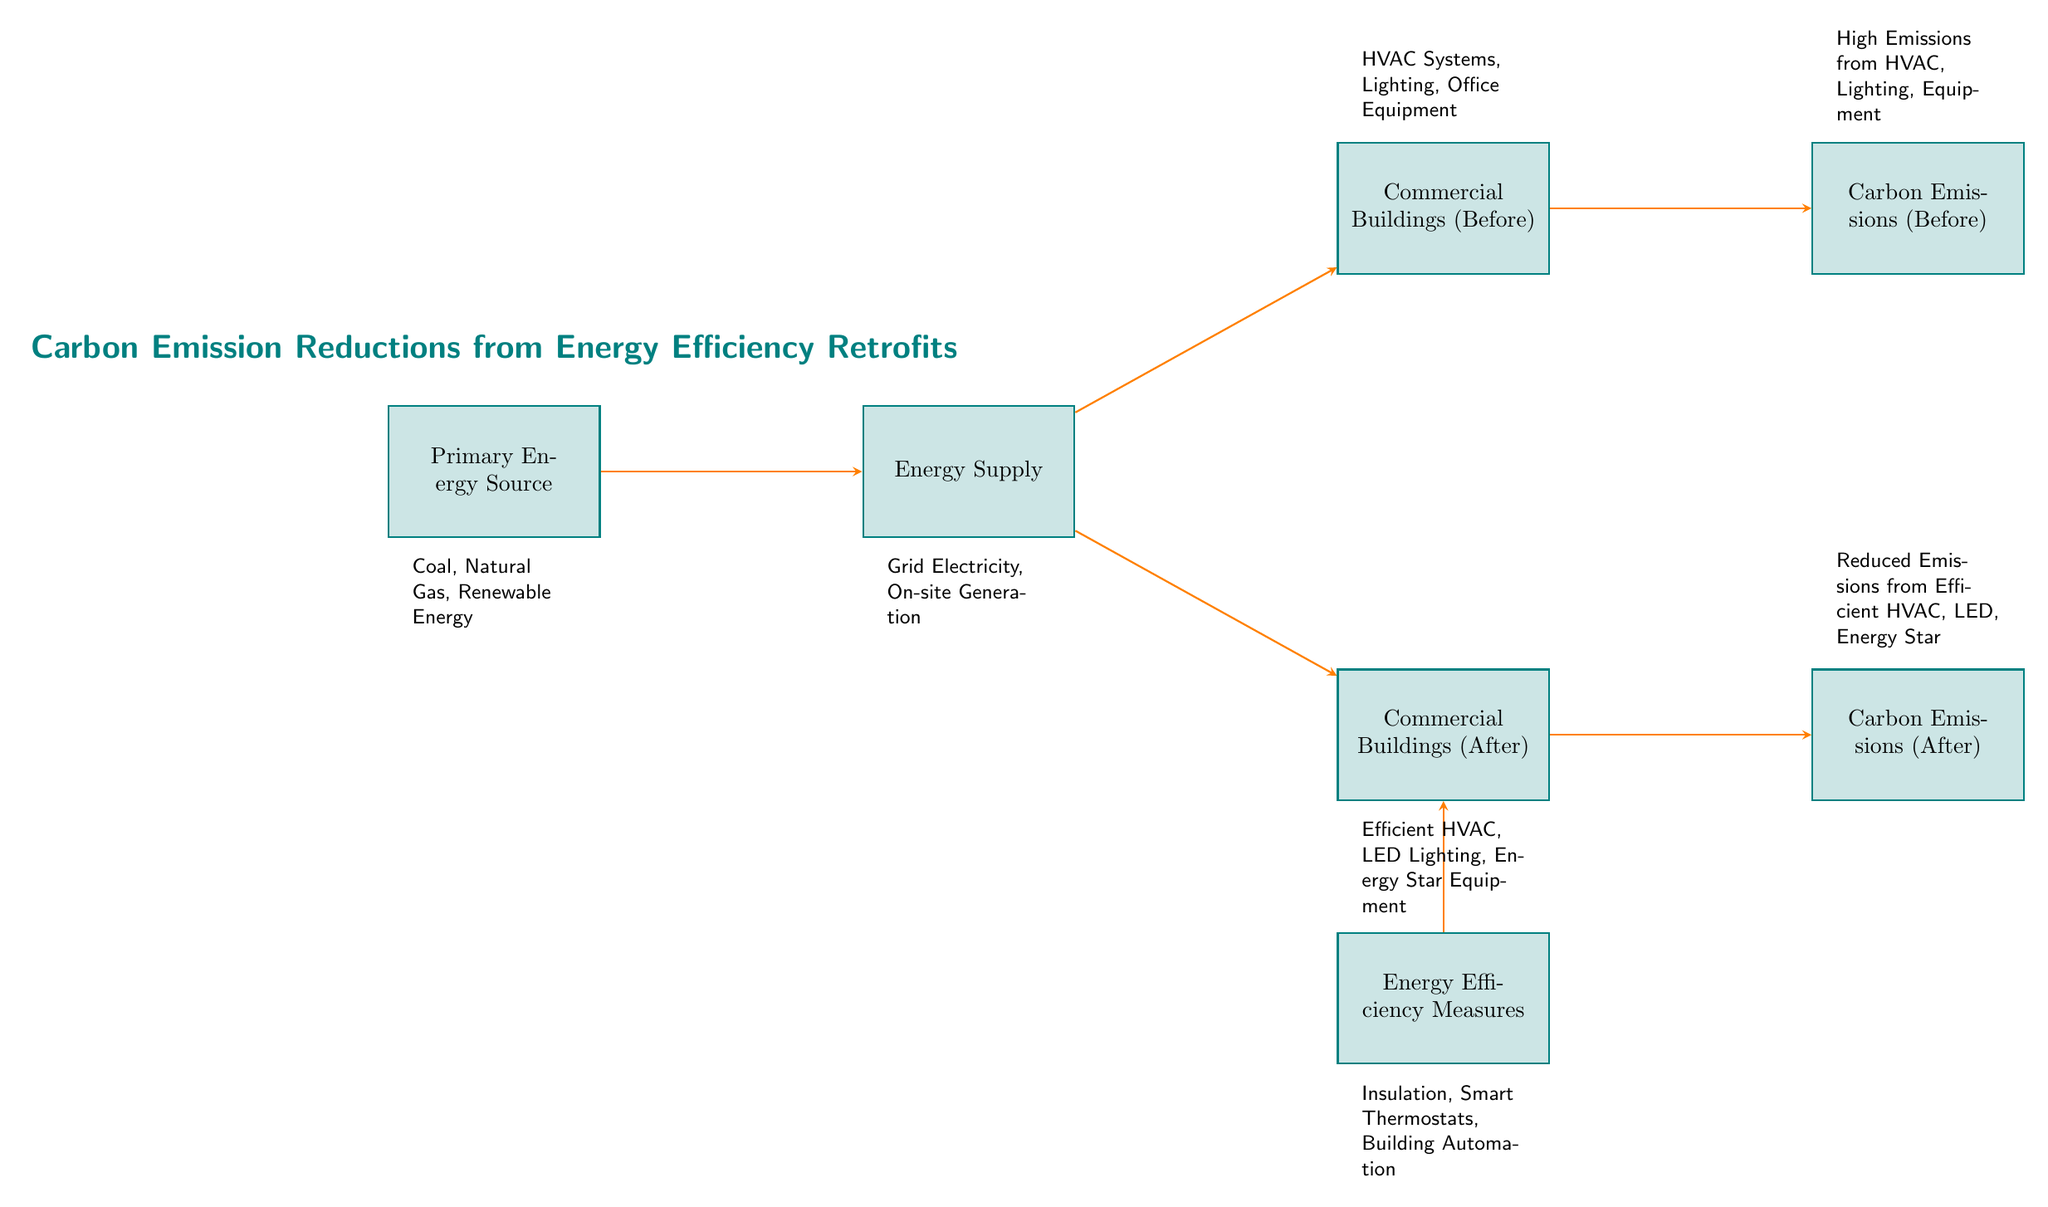What are the primary energy sources shown in the diagram? The diagram identifies the primary energy sources as coal, natural gas, and renewable energy, all listed below the 'Primary Energy Source' node.
Answer: Coal, Natural Gas, Renewable Energy Which types of energy supply are mentioned? The types of energy supply mentioned in the diagram include grid electricity and on-site generation, which are located below the 'Energy Supply' node.
Answer: Grid Electricity, On-site Generation How many carbon emissions nodes are present in the diagram? There are two carbon emissions nodes present: one representing emissions before the retrofits and another for emissions after the retrofits, identified as 'Carbon Emissions (Before)' and 'Carbon Emissions (After)'.
Answer: 2 What efficiency measures are listed in the diagram? The diagram includes insulation, smart thermostats, and building automation as energy efficiency measures listed below the 'Energy Efficiency Measures' node.
Answer: Insulation, Smart Thermostats, Building Automation What impacts do the efficiency measures have on carbon emissions in commercial buildings? The efficiency measures in the diagram lead to reduced emissions from efficient HVAC systems, LED lighting, and Energy Star equipment after the retrofits, as indicated next to the 'Carbon Emissions (After)' node.
Answer: Reduced Emissions What relationship exists between energy efficiency measures and commercial buildings after retrofits? Energy efficiency measures directly impact commercial buildings after retrofits, as indicated by the arrow connecting 'Energy Efficiency Measures' to 'Commercial Buildings (After)', suggesting that these measures enhance building performance.
Answer: Direct impact What defines the emissions status before implementing efficiency measures? The emissions status before implementing efficiency measures is characterized by high emissions from HVAC systems, lighting, and equipment, described next to the 'Carbon Emissions (Before)' node in the diagram.
Answer: High Emissions What is the flow direction of energy in this diagram? The flow direction in the diagram moves from primary energy sources through energy supply to commercial buildings, indicating the pathway for energy and its consequent impact on carbon emissions.
Answer: From sources to emissions 